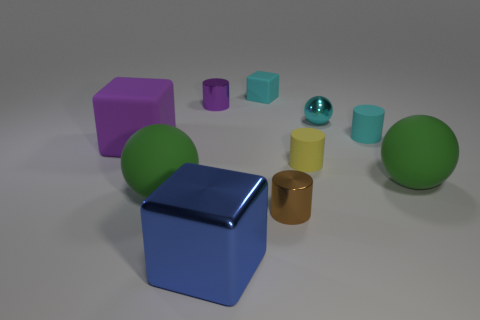Subtract all small cyan balls. How many balls are left? 2 Subtract 3 spheres. How many spheres are left? 0 Subtract all cyan spheres. How many spheres are left? 2 Subtract all cylinders. How many objects are left? 6 Add 1 brown shiny cylinders. How many brown shiny cylinders are left? 2 Add 5 cubes. How many cubes exist? 8 Subtract 0 brown cubes. How many objects are left? 10 Subtract all purple cubes. Subtract all purple cylinders. How many cubes are left? 2 Subtract all green spheres. How many blue blocks are left? 1 Subtract all big purple cubes. Subtract all tiny red metal balls. How many objects are left? 9 